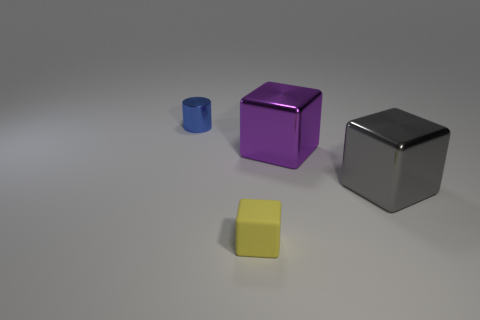Is the number of big gray metallic cubes that are in front of the gray metal cube less than the number of tiny blue objects?
Offer a very short reply. Yes. Is the tiny yellow thing made of the same material as the big cube to the right of the purple object?
Give a very brief answer. No. What is the small cube made of?
Your response must be concise. Rubber. What is the material of the object that is on the left side of the tiny object in front of the tiny thing that is left of the yellow matte thing?
Provide a succinct answer. Metal. Do the cylinder and the large metallic thing in front of the big purple cube have the same color?
Provide a succinct answer. No. Is there anything else that is the same shape as the large purple metallic object?
Ensure brevity in your answer.  Yes. What color is the tiny thing that is to the right of the metal thing that is left of the rubber thing?
Provide a short and direct response. Yellow. What number of big blue balls are there?
Offer a terse response. 0. How many matte objects are either blue objects or big purple spheres?
Keep it short and to the point. 0. How many small shiny objects are the same color as the matte object?
Make the answer very short. 0. 